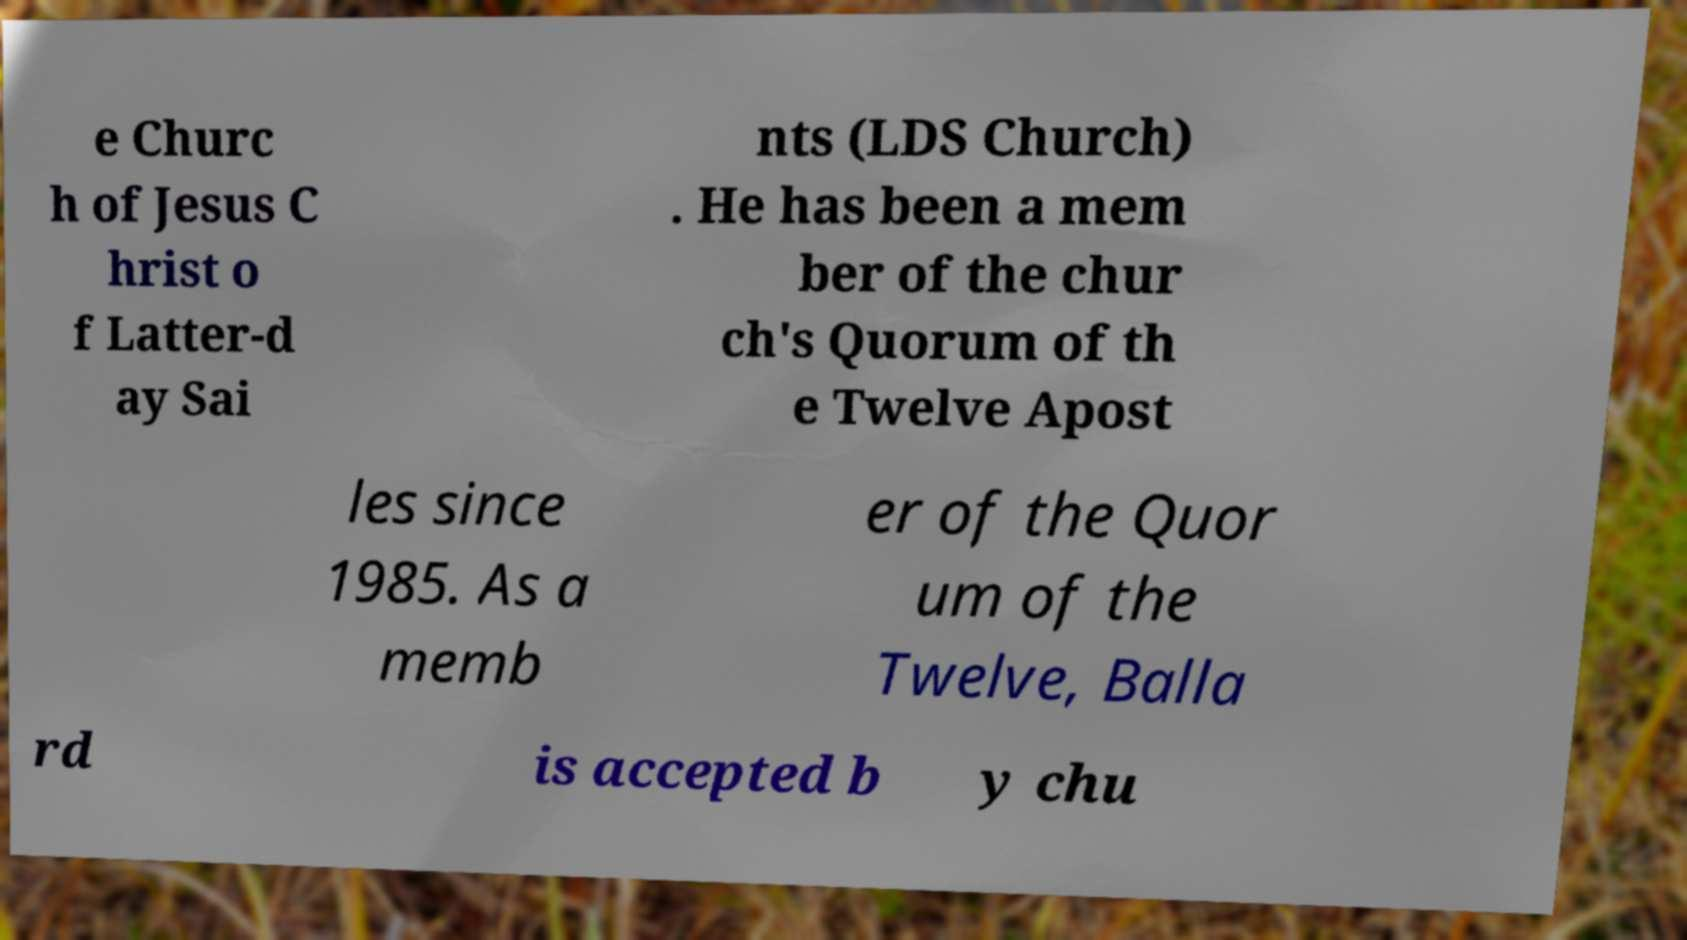Could you assist in decoding the text presented in this image and type it out clearly? e Churc h of Jesus C hrist o f Latter-d ay Sai nts (LDS Church) . He has been a mem ber of the chur ch's Quorum of th e Twelve Apost les since 1985. As a memb er of the Quor um of the Twelve, Balla rd is accepted b y chu 